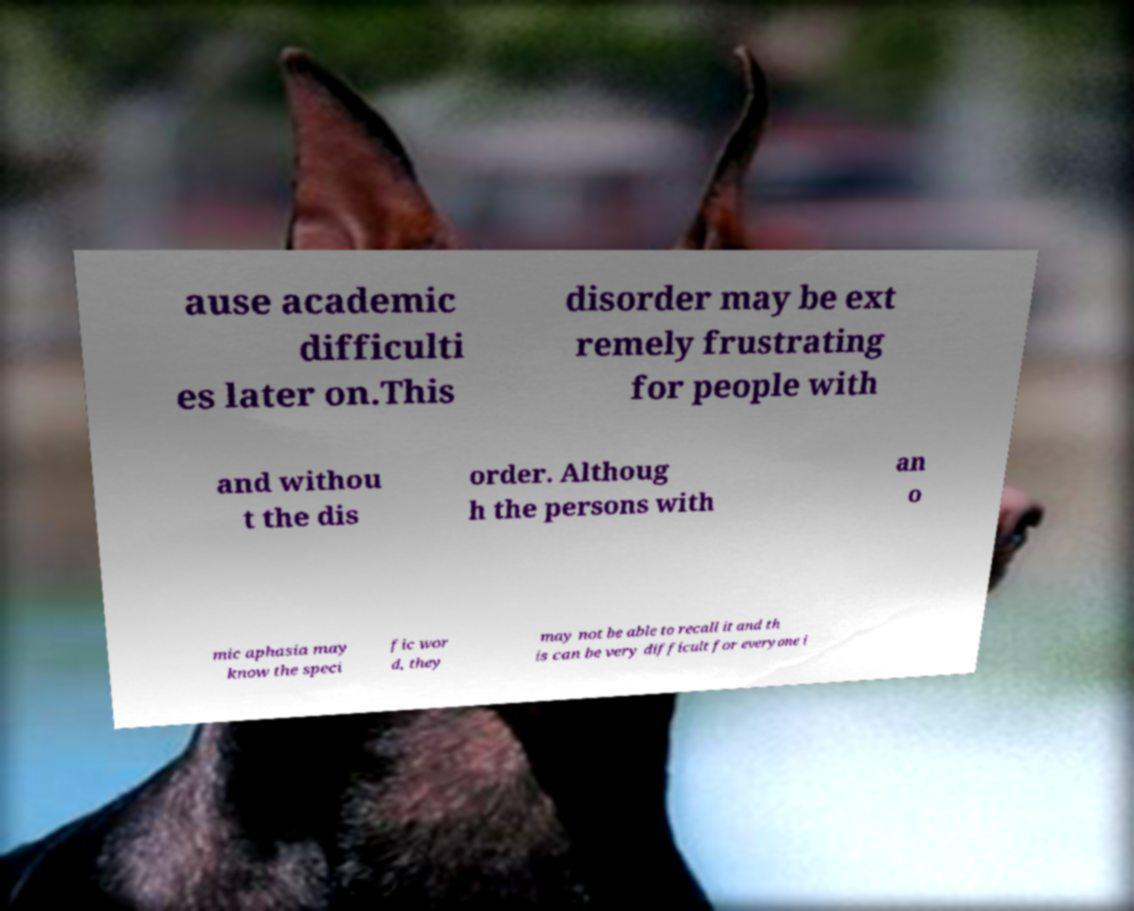Can you accurately transcribe the text from the provided image for me? ause academic difficulti es later on.This disorder may be ext remely frustrating for people with and withou t the dis order. Althoug h the persons with an o mic aphasia may know the speci fic wor d, they may not be able to recall it and th is can be very difficult for everyone i 